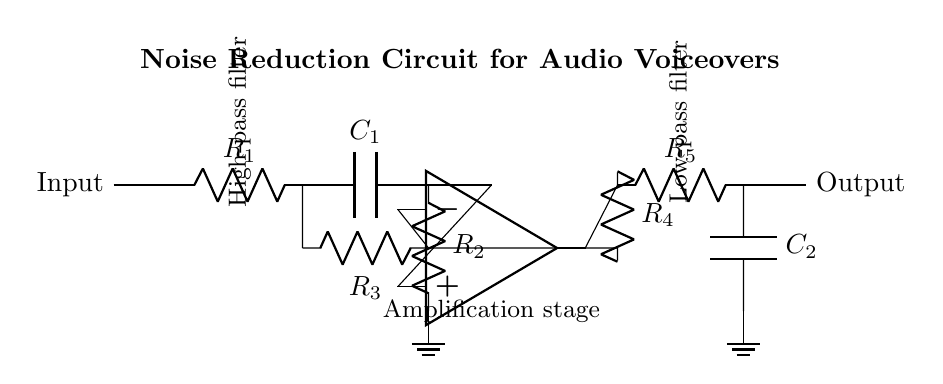What is the first component in the circuit? The first component in the circuit is a resistor labeled R1, which is the first element in the signal path.
Answer: R1 What is the function of C1 in this circuit? C1 is a capacitor used in the high-pass filter section of the circuit, allowing high-frequency signals to pass through while attenuating low-frequency noise.
Answer: High-pass filter How many resistors are in this circuit? There are five resistors in the circuit: R1, R2, R3, R4, and R5. Each is critical for filtering and amplification.
Answer: Five What type of amplifier is used in this circuit? The circuit utilizes an operational amplifier, indicated in the diagram, commonly used for signal processing tasks such as amplification.
Answer: Operational amplifier What is the purpose of the feedback loop with R4? The feedback loop with R4 in the op-amp configuration helps determine the gain of the circuit by feeding some output back into the inverting input, stabilizing and controlling the output signal.
Answer: Gain control Which part of the circuit acts as a low-pass filter? The low-pass filter is made up of the resistor R5 and the capacitor C2, allowing low-frequency signals to pass while attenuating high-frequency noise.
Answer: R5 and C2 